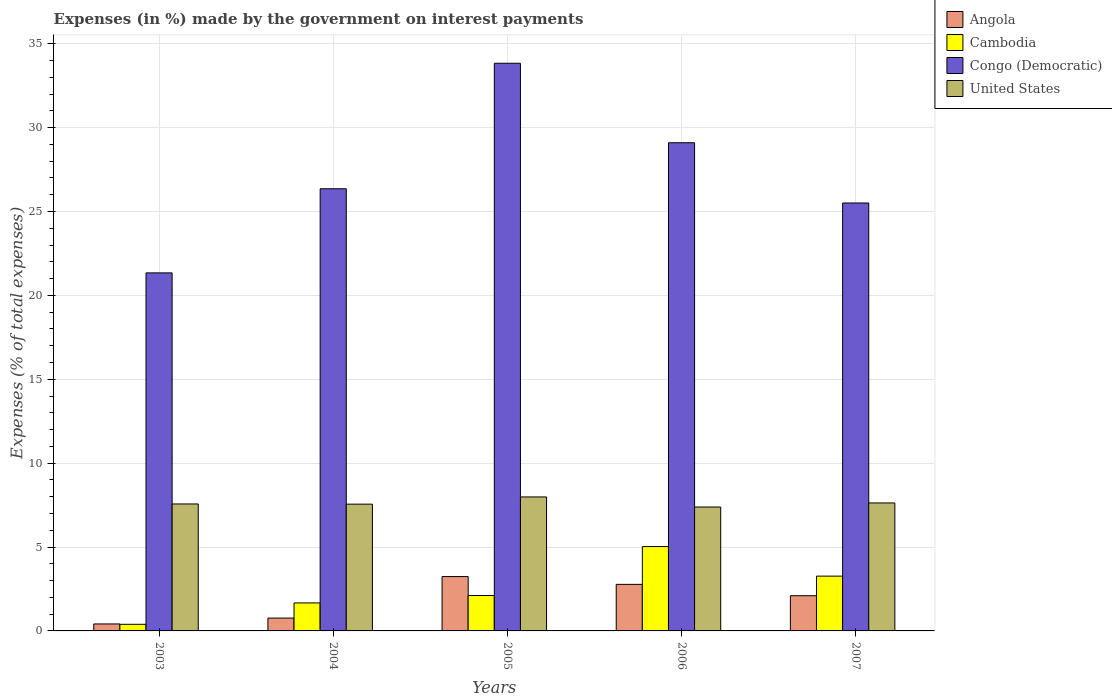How many different coloured bars are there?
Ensure brevity in your answer.  4. How many groups of bars are there?
Offer a terse response. 5. Are the number of bars per tick equal to the number of legend labels?
Your answer should be very brief. Yes. Are the number of bars on each tick of the X-axis equal?
Give a very brief answer. Yes. How many bars are there on the 3rd tick from the left?
Offer a terse response. 4. How many bars are there on the 5th tick from the right?
Give a very brief answer. 4. What is the label of the 1st group of bars from the left?
Your answer should be very brief. 2003. In how many cases, is the number of bars for a given year not equal to the number of legend labels?
Your response must be concise. 0. What is the percentage of expenses made by the government on interest payments in Cambodia in 2004?
Provide a succinct answer. 1.67. Across all years, what is the maximum percentage of expenses made by the government on interest payments in United States?
Provide a succinct answer. 7.99. Across all years, what is the minimum percentage of expenses made by the government on interest payments in Cambodia?
Your answer should be very brief. 0.39. What is the total percentage of expenses made by the government on interest payments in Congo (Democratic) in the graph?
Ensure brevity in your answer.  136.15. What is the difference between the percentage of expenses made by the government on interest payments in Angola in 2004 and that in 2005?
Provide a short and direct response. -2.48. What is the difference between the percentage of expenses made by the government on interest payments in United States in 2007 and the percentage of expenses made by the government on interest payments in Angola in 2005?
Your answer should be compact. 4.39. What is the average percentage of expenses made by the government on interest payments in Cambodia per year?
Keep it short and to the point. 2.49. In the year 2007, what is the difference between the percentage of expenses made by the government on interest payments in Cambodia and percentage of expenses made by the government on interest payments in United States?
Your answer should be very brief. -4.36. In how many years, is the percentage of expenses made by the government on interest payments in Angola greater than 18 %?
Your answer should be very brief. 0. What is the ratio of the percentage of expenses made by the government on interest payments in Congo (Democratic) in 2004 to that in 2005?
Offer a very short reply. 0.78. Is the percentage of expenses made by the government on interest payments in Cambodia in 2004 less than that in 2007?
Offer a very short reply. Yes. What is the difference between the highest and the second highest percentage of expenses made by the government on interest payments in Cambodia?
Your answer should be compact. 1.76. What is the difference between the highest and the lowest percentage of expenses made by the government on interest payments in Angola?
Provide a succinct answer. 2.82. What does the 1st bar from the left in 2007 represents?
Offer a very short reply. Angola. What does the 3rd bar from the right in 2006 represents?
Keep it short and to the point. Cambodia. How many bars are there?
Provide a succinct answer. 20. Are all the bars in the graph horizontal?
Ensure brevity in your answer.  No. How many years are there in the graph?
Your response must be concise. 5. Are the values on the major ticks of Y-axis written in scientific E-notation?
Ensure brevity in your answer.  No. Does the graph contain grids?
Keep it short and to the point. Yes. How many legend labels are there?
Make the answer very short. 4. What is the title of the graph?
Your answer should be compact. Expenses (in %) made by the government on interest payments. Does "Japan" appear as one of the legend labels in the graph?
Offer a very short reply. No. What is the label or title of the X-axis?
Provide a short and direct response. Years. What is the label or title of the Y-axis?
Ensure brevity in your answer.  Expenses (% of total expenses). What is the Expenses (% of total expenses) of Angola in 2003?
Your response must be concise. 0.42. What is the Expenses (% of total expenses) of Cambodia in 2003?
Make the answer very short. 0.39. What is the Expenses (% of total expenses) in Congo (Democratic) in 2003?
Provide a succinct answer. 21.34. What is the Expenses (% of total expenses) of United States in 2003?
Make the answer very short. 7.57. What is the Expenses (% of total expenses) in Angola in 2004?
Offer a terse response. 0.76. What is the Expenses (% of total expenses) of Cambodia in 2004?
Your answer should be very brief. 1.67. What is the Expenses (% of total expenses) of Congo (Democratic) in 2004?
Ensure brevity in your answer.  26.36. What is the Expenses (% of total expenses) in United States in 2004?
Make the answer very short. 7.56. What is the Expenses (% of total expenses) of Angola in 2005?
Ensure brevity in your answer.  3.24. What is the Expenses (% of total expenses) in Cambodia in 2005?
Your answer should be compact. 2.11. What is the Expenses (% of total expenses) in Congo (Democratic) in 2005?
Make the answer very short. 33.84. What is the Expenses (% of total expenses) of United States in 2005?
Your answer should be compact. 7.99. What is the Expenses (% of total expenses) in Angola in 2006?
Offer a very short reply. 2.78. What is the Expenses (% of total expenses) in Cambodia in 2006?
Your answer should be very brief. 5.03. What is the Expenses (% of total expenses) in Congo (Democratic) in 2006?
Ensure brevity in your answer.  29.1. What is the Expenses (% of total expenses) in United States in 2006?
Give a very brief answer. 7.39. What is the Expenses (% of total expenses) in Angola in 2007?
Offer a very short reply. 2.1. What is the Expenses (% of total expenses) in Cambodia in 2007?
Give a very brief answer. 3.27. What is the Expenses (% of total expenses) in Congo (Democratic) in 2007?
Your answer should be very brief. 25.51. What is the Expenses (% of total expenses) of United States in 2007?
Provide a short and direct response. 7.63. Across all years, what is the maximum Expenses (% of total expenses) of Angola?
Make the answer very short. 3.24. Across all years, what is the maximum Expenses (% of total expenses) of Cambodia?
Provide a short and direct response. 5.03. Across all years, what is the maximum Expenses (% of total expenses) of Congo (Democratic)?
Ensure brevity in your answer.  33.84. Across all years, what is the maximum Expenses (% of total expenses) in United States?
Provide a succinct answer. 7.99. Across all years, what is the minimum Expenses (% of total expenses) of Angola?
Make the answer very short. 0.42. Across all years, what is the minimum Expenses (% of total expenses) of Cambodia?
Provide a short and direct response. 0.39. Across all years, what is the minimum Expenses (% of total expenses) in Congo (Democratic)?
Provide a succinct answer. 21.34. Across all years, what is the minimum Expenses (% of total expenses) of United States?
Ensure brevity in your answer.  7.39. What is the total Expenses (% of total expenses) in Angola in the graph?
Provide a succinct answer. 9.29. What is the total Expenses (% of total expenses) in Cambodia in the graph?
Your answer should be compact. 12.47. What is the total Expenses (% of total expenses) of Congo (Democratic) in the graph?
Your answer should be compact. 136.15. What is the total Expenses (% of total expenses) of United States in the graph?
Offer a terse response. 38.13. What is the difference between the Expenses (% of total expenses) in Angola in 2003 and that in 2004?
Your response must be concise. -0.35. What is the difference between the Expenses (% of total expenses) of Cambodia in 2003 and that in 2004?
Make the answer very short. -1.27. What is the difference between the Expenses (% of total expenses) in Congo (Democratic) in 2003 and that in 2004?
Your answer should be very brief. -5.01. What is the difference between the Expenses (% of total expenses) in United States in 2003 and that in 2004?
Offer a terse response. 0.01. What is the difference between the Expenses (% of total expenses) in Angola in 2003 and that in 2005?
Make the answer very short. -2.82. What is the difference between the Expenses (% of total expenses) of Cambodia in 2003 and that in 2005?
Give a very brief answer. -1.72. What is the difference between the Expenses (% of total expenses) in Congo (Democratic) in 2003 and that in 2005?
Offer a terse response. -12.5. What is the difference between the Expenses (% of total expenses) of United States in 2003 and that in 2005?
Provide a short and direct response. -0.42. What is the difference between the Expenses (% of total expenses) in Angola in 2003 and that in 2006?
Provide a succinct answer. -2.36. What is the difference between the Expenses (% of total expenses) in Cambodia in 2003 and that in 2006?
Your response must be concise. -4.63. What is the difference between the Expenses (% of total expenses) of Congo (Democratic) in 2003 and that in 2006?
Your answer should be compact. -7.76. What is the difference between the Expenses (% of total expenses) of United States in 2003 and that in 2006?
Your answer should be very brief. 0.18. What is the difference between the Expenses (% of total expenses) in Angola in 2003 and that in 2007?
Offer a very short reply. -1.68. What is the difference between the Expenses (% of total expenses) in Cambodia in 2003 and that in 2007?
Your response must be concise. -2.87. What is the difference between the Expenses (% of total expenses) in Congo (Democratic) in 2003 and that in 2007?
Your response must be concise. -4.17. What is the difference between the Expenses (% of total expenses) in United States in 2003 and that in 2007?
Provide a short and direct response. -0.06. What is the difference between the Expenses (% of total expenses) in Angola in 2004 and that in 2005?
Offer a terse response. -2.48. What is the difference between the Expenses (% of total expenses) in Cambodia in 2004 and that in 2005?
Your answer should be very brief. -0.44. What is the difference between the Expenses (% of total expenses) of Congo (Democratic) in 2004 and that in 2005?
Ensure brevity in your answer.  -7.48. What is the difference between the Expenses (% of total expenses) of United States in 2004 and that in 2005?
Provide a succinct answer. -0.43. What is the difference between the Expenses (% of total expenses) of Angola in 2004 and that in 2006?
Your response must be concise. -2.01. What is the difference between the Expenses (% of total expenses) in Cambodia in 2004 and that in 2006?
Offer a terse response. -3.36. What is the difference between the Expenses (% of total expenses) of Congo (Democratic) in 2004 and that in 2006?
Provide a short and direct response. -2.74. What is the difference between the Expenses (% of total expenses) of United States in 2004 and that in 2006?
Keep it short and to the point. 0.17. What is the difference between the Expenses (% of total expenses) of Angola in 2004 and that in 2007?
Provide a succinct answer. -1.33. What is the difference between the Expenses (% of total expenses) in Cambodia in 2004 and that in 2007?
Provide a short and direct response. -1.6. What is the difference between the Expenses (% of total expenses) in Congo (Democratic) in 2004 and that in 2007?
Your answer should be very brief. 0.85. What is the difference between the Expenses (% of total expenses) of United States in 2004 and that in 2007?
Provide a succinct answer. -0.07. What is the difference between the Expenses (% of total expenses) in Angola in 2005 and that in 2006?
Provide a short and direct response. 0.46. What is the difference between the Expenses (% of total expenses) of Cambodia in 2005 and that in 2006?
Your answer should be compact. -2.92. What is the difference between the Expenses (% of total expenses) in Congo (Democratic) in 2005 and that in 2006?
Your answer should be very brief. 4.74. What is the difference between the Expenses (% of total expenses) in United States in 2005 and that in 2006?
Offer a terse response. 0.6. What is the difference between the Expenses (% of total expenses) in Angola in 2005 and that in 2007?
Make the answer very short. 1.14. What is the difference between the Expenses (% of total expenses) in Cambodia in 2005 and that in 2007?
Give a very brief answer. -1.15. What is the difference between the Expenses (% of total expenses) of Congo (Democratic) in 2005 and that in 2007?
Provide a succinct answer. 8.33. What is the difference between the Expenses (% of total expenses) in United States in 2005 and that in 2007?
Your answer should be compact. 0.36. What is the difference between the Expenses (% of total expenses) of Angola in 2006 and that in 2007?
Provide a succinct answer. 0.68. What is the difference between the Expenses (% of total expenses) in Cambodia in 2006 and that in 2007?
Offer a very short reply. 1.76. What is the difference between the Expenses (% of total expenses) in Congo (Democratic) in 2006 and that in 2007?
Your answer should be compact. 3.59. What is the difference between the Expenses (% of total expenses) of United States in 2006 and that in 2007?
Offer a terse response. -0.24. What is the difference between the Expenses (% of total expenses) in Angola in 2003 and the Expenses (% of total expenses) in Cambodia in 2004?
Offer a terse response. -1.25. What is the difference between the Expenses (% of total expenses) in Angola in 2003 and the Expenses (% of total expenses) in Congo (Democratic) in 2004?
Your answer should be very brief. -25.94. What is the difference between the Expenses (% of total expenses) of Angola in 2003 and the Expenses (% of total expenses) of United States in 2004?
Offer a terse response. -7.14. What is the difference between the Expenses (% of total expenses) of Cambodia in 2003 and the Expenses (% of total expenses) of Congo (Democratic) in 2004?
Give a very brief answer. -25.96. What is the difference between the Expenses (% of total expenses) in Cambodia in 2003 and the Expenses (% of total expenses) in United States in 2004?
Offer a very short reply. -7.16. What is the difference between the Expenses (% of total expenses) in Congo (Democratic) in 2003 and the Expenses (% of total expenses) in United States in 2004?
Provide a short and direct response. 13.79. What is the difference between the Expenses (% of total expenses) in Angola in 2003 and the Expenses (% of total expenses) in Cambodia in 2005?
Give a very brief answer. -1.7. What is the difference between the Expenses (% of total expenses) in Angola in 2003 and the Expenses (% of total expenses) in Congo (Democratic) in 2005?
Provide a succinct answer. -33.42. What is the difference between the Expenses (% of total expenses) in Angola in 2003 and the Expenses (% of total expenses) in United States in 2005?
Ensure brevity in your answer.  -7.57. What is the difference between the Expenses (% of total expenses) of Cambodia in 2003 and the Expenses (% of total expenses) of Congo (Democratic) in 2005?
Your response must be concise. -33.44. What is the difference between the Expenses (% of total expenses) of Cambodia in 2003 and the Expenses (% of total expenses) of United States in 2005?
Provide a succinct answer. -7.59. What is the difference between the Expenses (% of total expenses) of Congo (Democratic) in 2003 and the Expenses (% of total expenses) of United States in 2005?
Offer a terse response. 13.36. What is the difference between the Expenses (% of total expenses) of Angola in 2003 and the Expenses (% of total expenses) of Cambodia in 2006?
Keep it short and to the point. -4.61. What is the difference between the Expenses (% of total expenses) of Angola in 2003 and the Expenses (% of total expenses) of Congo (Democratic) in 2006?
Your answer should be compact. -28.68. What is the difference between the Expenses (% of total expenses) of Angola in 2003 and the Expenses (% of total expenses) of United States in 2006?
Your answer should be very brief. -6.97. What is the difference between the Expenses (% of total expenses) of Cambodia in 2003 and the Expenses (% of total expenses) of Congo (Democratic) in 2006?
Offer a terse response. -28.71. What is the difference between the Expenses (% of total expenses) of Cambodia in 2003 and the Expenses (% of total expenses) of United States in 2006?
Provide a succinct answer. -6.99. What is the difference between the Expenses (% of total expenses) of Congo (Democratic) in 2003 and the Expenses (% of total expenses) of United States in 2006?
Give a very brief answer. 13.96. What is the difference between the Expenses (% of total expenses) in Angola in 2003 and the Expenses (% of total expenses) in Cambodia in 2007?
Your response must be concise. -2.85. What is the difference between the Expenses (% of total expenses) of Angola in 2003 and the Expenses (% of total expenses) of Congo (Democratic) in 2007?
Keep it short and to the point. -25.09. What is the difference between the Expenses (% of total expenses) of Angola in 2003 and the Expenses (% of total expenses) of United States in 2007?
Give a very brief answer. -7.21. What is the difference between the Expenses (% of total expenses) of Cambodia in 2003 and the Expenses (% of total expenses) of Congo (Democratic) in 2007?
Offer a very short reply. -25.11. What is the difference between the Expenses (% of total expenses) of Cambodia in 2003 and the Expenses (% of total expenses) of United States in 2007?
Ensure brevity in your answer.  -7.23. What is the difference between the Expenses (% of total expenses) in Congo (Democratic) in 2003 and the Expenses (% of total expenses) in United States in 2007?
Offer a terse response. 13.71. What is the difference between the Expenses (% of total expenses) in Angola in 2004 and the Expenses (% of total expenses) in Cambodia in 2005?
Keep it short and to the point. -1.35. What is the difference between the Expenses (% of total expenses) in Angola in 2004 and the Expenses (% of total expenses) in Congo (Democratic) in 2005?
Give a very brief answer. -33.07. What is the difference between the Expenses (% of total expenses) of Angola in 2004 and the Expenses (% of total expenses) of United States in 2005?
Ensure brevity in your answer.  -7.22. What is the difference between the Expenses (% of total expenses) of Cambodia in 2004 and the Expenses (% of total expenses) of Congo (Democratic) in 2005?
Provide a short and direct response. -32.17. What is the difference between the Expenses (% of total expenses) in Cambodia in 2004 and the Expenses (% of total expenses) in United States in 2005?
Keep it short and to the point. -6.32. What is the difference between the Expenses (% of total expenses) in Congo (Democratic) in 2004 and the Expenses (% of total expenses) in United States in 2005?
Give a very brief answer. 18.37. What is the difference between the Expenses (% of total expenses) in Angola in 2004 and the Expenses (% of total expenses) in Cambodia in 2006?
Your response must be concise. -4.26. What is the difference between the Expenses (% of total expenses) of Angola in 2004 and the Expenses (% of total expenses) of Congo (Democratic) in 2006?
Your response must be concise. -28.34. What is the difference between the Expenses (% of total expenses) of Angola in 2004 and the Expenses (% of total expenses) of United States in 2006?
Your answer should be compact. -6.62. What is the difference between the Expenses (% of total expenses) of Cambodia in 2004 and the Expenses (% of total expenses) of Congo (Democratic) in 2006?
Your answer should be compact. -27.43. What is the difference between the Expenses (% of total expenses) in Cambodia in 2004 and the Expenses (% of total expenses) in United States in 2006?
Your response must be concise. -5.72. What is the difference between the Expenses (% of total expenses) of Congo (Democratic) in 2004 and the Expenses (% of total expenses) of United States in 2006?
Your response must be concise. 18.97. What is the difference between the Expenses (% of total expenses) in Angola in 2004 and the Expenses (% of total expenses) in Cambodia in 2007?
Keep it short and to the point. -2.5. What is the difference between the Expenses (% of total expenses) of Angola in 2004 and the Expenses (% of total expenses) of Congo (Democratic) in 2007?
Your answer should be very brief. -24.74. What is the difference between the Expenses (% of total expenses) in Angola in 2004 and the Expenses (% of total expenses) in United States in 2007?
Give a very brief answer. -6.86. What is the difference between the Expenses (% of total expenses) of Cambodia in 2004 and the Expenses (% of total expenses) of Congo (Democratic) in 2007?
Your answer should be compact. -23.84. What is the difference between the Expenses (% of total expenses) of Cambodia in 2004 and the Expenses (% of total expenses) of United States in 2007?
Offer a terse response. -5.96. What is the difference between the Expenses (% of total expenses) of Congo (Democratic) in 2004 and the Expenses (% of total expenses) of United States in 2007?
Your answer should be compact. 18.73. What is the difference between the Expenses (% of total expenses) in Angola in 2005 and the Expenses (% of total expenses) in Cambodia in 2006?
Provide a succinct answer. -1.79. What is the difference between the Expenses (% of total expenses) in Angola in 2005 and the Expenses (% of total expenses) in Congo (Democratic) in 2006?
Give a very brief answer. -25.86. What is the difference between the Expenses (% of total expenses) of Angola in 2005 and the Expenses (% of total expenses) of United States in 2006?
Keep it short and to the point. -4.15. What is the difference between the Expenses (% of total expenses) in Cambodia in 2005 and the Expenses (% of total expenses) in Congo (Democratic) in 2006?
Offer a terse response. -26.99. What is the difference between the Expenses (% of total expenses) in Cambodia in 2005 and the Expenses (% of total expenses) in United States in 2006?
Give a very brief answer. -5.27. What is the difference between the Expenses (% of total expenses) in Congo (Democratic) in 2005 and the Expenses (% of total expenses) in United States in 2006?
Provide a succinct answer. 26.45. What is the difference between the Expenses (% of total expenses) of Angola in 2005 and the Expenses (% of total expenses) of Cambodia in 2007?
Provide a succinct answer. -0.03. What is the difference between the Expenses (% of total expenses) of Angola in 2005 and the Expenses (% of total expenses) of Congo (Democratic) in 2007?
Your response must be concise. -22.27. What is the difference between the Expenses (% of total expenses) in Angola in 2005 and the Expenses (% of total expenses) in United States in 2007?
Ensure brevity in your answer.  -4.39. What is the difference between the Expenses (% of total expenses) of Cambodia in 2005 and the Expenses (% of total expenses) of Congo (Democratic) in 2007?
Provide a short and direct response. -23.4. What is the difference between the Expenses (% of total expenses) of Cambodia in 2005 and the Expenses (% of total expenses) of United States in 2007?
Your answer should be compact. -5.52. What is the difference between the Expenses (% of total expenses) in Congo (Democratic) in 2005 and the Expenses (% of total expenses) in United States in 2007?
Your answer should be very brief. 26.21. What is the difference between the Expenses (% of total expenses) in Angola in 2006 and the Expenses (% of total expenses) in Cambodia in 2007?
Make the answer very short. -0.49. What is the difference between the Expenses (% of total expenses) in Angola in 2006 and the Expenses (% of total expenses) in Congo (Democratic) in 2007?
Provide a succinct answer. -22.73. What is the difference between the Expenses (% of total expenses) in Angola in 2006 and the Expenses (% of total expenses) in United States in 2007?
Give a very brief answer. -4.85. What is the difference between the Expenses (% of total expenses) in Cambodia in 2006 and the Expenses (% of total expenses) in Congo (Democratic) in 2007?
Provide a short and direct response. -20.48. What is the difference between the Expenses (% of total expenses) of Cambodia in 2006 and the Expenses (% of total expenses) of United States in 2007?
Make the answer very short. -2.6. What is the difference between the Expenses (% of total expenses) of Congo (Democratic) in 2006 and the Expenses (% of total expenses) of United States in 2007?
Give a very brief answer. 21.47. What is the average Expenses (% of total expenses) in Angola per year?
Make the answer very short. 1.86. What is the average Expenses (% of total expenses) in Cambodia per year?
Make the answer very short. 2.49. What is the average Expenses (% of total expenses) in Congo (Democratic) per year?
Make the answer very short. 27.23. What is the average Expenses (% of total expenses) in United States per year?
Offer a terse response. 7.62. In the year 2003, what is the difference between the Expenses (% of total expenses) of Angola and Expenses (% of total expenses) of Cambodia?
Keep it short and to the point. 0.02. In the year 2003, what is the difference between the Expenses (% of total expenses) of Angola and Expenses (% of total expenses) of Congo (Democratic)?
Your answer should be compact. -20.93. In the year 2003, what is the difference between the Expenses (% of total expenses) of Angola and Expenses (% of total expenses) of United States?
Offer a very short reply. -7.15. In the year 2003, what is the difference between the Expenses (% of total expenses) of Cambodia and Expenses (% of total expenses) of Congo (Democratic)?
Ensure brevity in your answer.  -20.95. In the year 2003, what is the difference between the Expenses (% of total expenses) in Cambodia and Expenses (% of total expenses) in United States?
Provide a succinct answer. -7.17. In the year 2003, what is the difference between the Expenses (% of total expenses) in Congo (Democratic) and Expenses (% of total expenses) in United States?
Keep it short and to the point. 13.77. In the year 2004, what is the difference between the Expenses (% of total expenses) in Angola and Expenses (% of total expenses) in Cambodia?
Provide a short and direct response. -0.9. In the year 2004, what is the difference between the Expenses (% of total expenses) of Angola and Expenses (% of total expenses) of Congo (Democratic)?
Offer a terse response. -25.59. In the year 2004, what is the difference between the Expenses (% of total expenses) in Angola and Expenses (% of total expenses) in United States?
Keep it short and to the point. -6.79. In the year 2004, what is the difference between the Expenses (% of total expenses) of Cambodia and Expenses (% of total expenses) of Congo (Democratic)?
Offer a very short reply. -24.69. In the year 2004, what is the difference between the Expenses (% of total expenses) of Cambodia and Expenses (% of total expenses) of United States?
Ensure brevity in your answer.  -5.89. In the year 2004, what is the difference between the Expenses (% of total expenses) of Congo (Democratic) and Expenses (% of total expenses) of United States?
Ensure brevity in your answer.  18.8. In the year 2005, what is the difference between the Expenses (% of total expenses) in Angola and Expenses (% of total expenses) in Cambodia?
Your answer should be compact. 1.13. In the year 2005, what is the difference between the Expenses (% of total expenses) of Angola and Expenses (% of total expenses) of Congo (Democratic)?
Offer a terse response. -30.6. In the year 2005, what is the difference between the Expenses (% of total expenses) in Angola and Expenses (% of total expenses) in United States?
Your response must be concise. -4.75. In the year 2005, what is the difference between the Expenses (% of total expenses) in Cambodia and Expenses (% of total expenses) in Congo (Democratic)?
Your answer should be very brief. -31.73. In the year 2005, what is the difference between the Expenses (% of total expenses) of Cambodia and Expenses (% of total expenses) of United States?
Provide a succinct answer. -5.87. In the year 2005, what is the difference between the Expenses (% of total expenses) of Congo (Democratic) and Expenses (% of total expenses) of United States?
Make the answer very short. 25.85. In the year 2006, what is the difference between the Expenses (% of total expenses) of Angola and Expenses (% of total expenses) of Cambodia?
Your answer should be very brief. -2.25. In the year 2006, what is the difference between the Expenses (% of total expenses) of Angola and Expenses (% of total expenses) of Congo (Democratic)?
Ensure brevity in your answer.  -26.33. In the year 2006, what is the difference between the Expenses (% of total expenses) in Angola and Expenses (% of total expenses) in United States?
Offer a very short reply. -4.61. In the year 2006, what is the difference between the Expenses (% of total expenses) in Cambodia and Expenses (% of total expenses) in Congo (Democratic)?
Your response must be concise. -24.07. In the year 2006, what is the difference between the Expenses (% of total expenses) of Cambodia and Expenses (% of total expenses) of United States?
Give a very brief answer. -2.36. In the year 2006, what is the difference between the Expenses (% of total expenses) of Congo (Democratic) and Expenses (% of total expenses) of United States?
Offer a very short reply. 21.71. In the year 2007, what is the difference between the Expenses (% of total expenses) of Angola and Expenses (% of total expenses) of Cambodia?
Your answer should be very brief. -1.17. In the year 2007, what is the difference between the Expenses (% of total expenses) in Angola and Expenses (% of total expenses) in Congo (Democratic)?
Provide a short and direct response. -23.41. In the year 2007, what is the difference between the Expenses (% of total expenses) of Angola and Expenses (% of total expenses) of United States?
Provide a short and direct response. -5.53. In the year 2007, what is the difference between the Expenses (% of total expenses) of Cambodia and Expenses (% of total expenses) of Congo (Democratic)?
Provide a succinct answer. -22.24. In the year 2007, what is the difference between the Expenses (% of total expenses) in Cambodia and Expenses (% of total expenses) in United States?
Make the answer very short. -4.36. In the year 2007, what is the difference between the Expenses (% of total expenses) of Congo (Democratic) and Expenses (% of total expenses) of United States?
Keep it short and to the point. 17.88. What is the ratio of the Expenses (% of total expenses) in Angola in 2003 to that in 2004?
Provide a succinct answer. 0.54. What is the ratio of the Expenses (% of total expenses) in Cambodia in 2003 to that in 2004?
Provide a short and direct response. 0.24. What is the ratio of the Expenses (% of total expenses) of Congo (Democratic) in 2003 to that in 2004?
Give a very brief answer. 0.81. What is the ratio of the Expenses (% of total expenses) in Angola in 2003 to that in 2005?
Provide a short and direct response. 0.13. What is the ratio of the Expenses (% of total expenses) in Cambodia in 2003 to that in 2005?
Your answer should be very brief. 0.19. What is the ratio of the Expenses (% of total expenses) in Congo (Democratic) in 2003 to that in 2005?
Provide a short and direct response. 0.63. What is the ratio of the Expenses (% of total expenses) of United States in 2003 to that in 2005?
Ensure brevity in your answer.  0.95. What is the ratio of the Expenses (% of total expenses) of Angola in 2003 to that in 2006?
Offer a very short reply. 0.15. What is the ratio of the Expenses (% of total expenses) in Cambodia in 2003 to that in 2006?
Keep it short and to the point. 0.08. What is the ratio of the Expenses (% of total expenses) of Congo (Democratic) in 2003 to that in 2006?
Offer a terse response. 0.73. What is the ratio of the Expenses (% of total expenses) of United States in 2003 to that in 2006?
Offer a very short reply. 1.02. What is the ratio of the Expenses (% of total expenses) of Angola in 2003 to that in 2007?
Give a very brief answer. 0.2. What is the ratio of the Expenses (% of total expenses) of Cambodia in 2003 to that in 2007?
Your response must be concise. 0.12. What is the ratio of the Expenses (% of total expenses) of Congo (Democratic) in 2003 to that in 2007?
Ensure brevity in your answer.  0.84. What is the ratio of the Expenses (% of total expenses) of United States in 2003 to that in 2007?
Provide a succinct answer. 0.99. What is the ratio of the Expenses (% of total expenses) of Angola in 2004 to that in 2005?
Your answer should be compact. 0.24. What is the ratio of the Expenses (% of total expenses) of Cambodia in 2004 to that in 2005?
Give a very brief answer. 0.79. What is the ratio of the Expenses (% of total expenses) in Congo (Democratic) in 2004 to that in 2005?
Offer a very short reply. 0.78. What is the ratio of the Expenses (% of total expenses) of United States in 2004 to that in 2005?
Your answer should be very brief. 0.95. What is the ratio of the Expenses (% of total expenses) in Angola in 2004 to that in 2006?
Your answer should be very brief. 0.28. What is the ratio of the Expenses (% of total expenses) in Cambodia in 2004 to that in 2006?
Your answer should be compact. 0.33. What is the ratio of the Expenses (% of total expenses) in Congo (Democratic) in 2004 to that in 2006?
Your answer should be very brief. 0.91. What is the ratio of the Expenses (% of total expenses) in United States in 2004 to that in 2006?
Offer a very short reply. 1.02. What is the ratio of the Expenses (% of total expenses) in Angola in 2004 to that in 2007?
Make the answer very short. 0.36. What is the ratio of the Expenses (% of total expenses) in Cambodia in 2004 to that in 2007?
Make the answer very short. 0.51. What is the ratio of the Expenses (% of total expenses) in United States in 2004 to that in 2007?
Ensure brevity in your answer.  0.99. What is the ratio of the Expenses (% of total expenses) in Angola in 2005 to that in 2006?
Offer a terse response. 1.17. What is the ratio of the Expenses (% of total expenses) in Cambodia in 2005 to that in 2006?
Make the answer very short. 0.42. What is the ratio of the Expenses (% of total expenses) in Congo (Democratic) in 2005 to that in 2006?
Provide a short and direct response. 1.16. What is the ratio of the Expenses (% of total expenses) of United States in 2005 to that in 2006?
Your answer should be compact. 1.08. What is the ratio of the Expenses (% of total expenses) of Angola in 2005 to that in 2007?
Ensure brevity in your answer.  1.54. What is the ratio of the Expenses (% of total expenses) in Cambodia in 2005 to that in 2007?
Offer a very short reply. 0.65. What is the ratio of the Expenses (% of total expenses) of Congo (Democratic) in 2005 to that in 2007?
Provide a short and direct response. 1.33. What is the ratio of the Expenses (% of total expenses) in United States in 2005 to that in 2007?
Provide a succinct answer. 1.05. What is the ratio of the Expenses (% of total expenses) of Angola in 2006 to that in 2007?
Keep it short and to the point. 1.32. What is the ratio of the Expenses (% of total expenses) in Cambodia in 2006 to that in 2007?
Your response must be concise. 1.54. What is the ratio of the Expenses (% of total expenses) of Congo (Democratic) in 2006 to that in 2007?
Offer a terse response. 1.14. What is the ratio of the Expenses (% of total expenses) of United States in 2006 to that in 2007?
Provide a short and direct response. 0.97. What is the difference between the highest and the second highest Expenses (% of total expenses) in Angola?
Offer a terse response. 0.46. What is the difference between the highest and the second highest Expenses (% of total expenses) of Cambodia?
Offer a very short reply. 1.76. What is the difference between the highest and the second highest Expenses (% of total expenses) of Congo (Democratic)?
Your answer should be very brief. 4.74. What is the difference between the highest and the second highest Expenses (% of total expenses) of United States?
Provide a short and direct response. 0.36. What is the difference between the highest and the lowest Expenses (% of total expenses) of Angola?
Give a very brief answer. 2.82. What is the difference between the highest and the lowest Expenses (% of total expenses) in Cambodia?
Make the answer very short. 4.63. What is the difference between the highest and the lowest Expenses (% of total expenses) in Congo (Democratic)?
Your response must be concise. 12.5. What is the difference between the highest and the lowest Expenses (% of total expenses) of United States?
Keep it short and to the point. 0.6. 